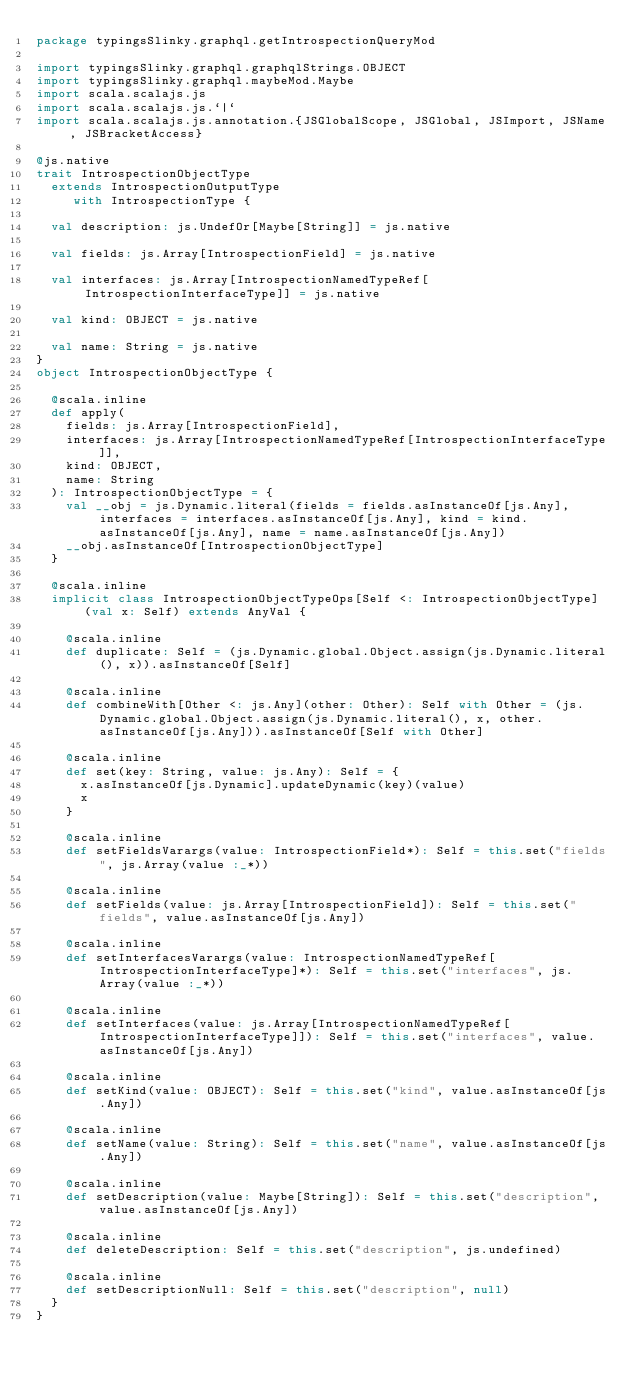Convert code to text. <code><loc_0><loc_0><loc_500><loc_500><_Scala_>package typingsSlinky.graphql.getIntrospectionQueryMod

import typingsSlinky.graphql.graphqlStrings.OBJECT
import typingsSlinky.graphql.maybeMod.Maybe
import scala.scalajs.js
import scala.scalajs.js.`|`
import scala.scalajs.js.annotation.{JSGlobalScope, JSGlobal, JSImport, JSName, JSBracketAccess}

@js.native
trait IntrospectionObjectType
  extends IntrospectionOutputType
     with IntrospectionType {
  
  val description: js.UndefOr[Maybe[String]] = js.native
  
  val fields: js.Array[IntrospectionField] = js.native
  
  val interfaces: js.Array[IntrospectionNamedTypeRef[IntrospectionInterfaceType]] = js.native
  
  val kind: OBJECT = js.native
  
  val name: String = js.native
}
object IntrospectionObjectType {
  
  @scala.inline
  def apply(
    fields: js.Array[IntrospectionField],
    interfaces: js.Array[IntrospectionNamedTypeRef[IntrospectionInterfaceType]],
    kind: OBJECT,
    name: String
  ): IntrospectionObjectType = {
    val __obj = js.Dynamic.literal(fields = fields.asInstanceOf[js.Any], interfaces = interfaces.asInstanceOf[js.Any], kind = kind.asInstanceOf[js.Any], name = name.asInstanceOf[js.Any])
    __obj.asInstanceOf[IntrospectionObjectType]
  }
  
  @scala.inline
  implicit class IntrospectionObjectTypeOps[Self <: IntrospectionObjectType] (val x: Self) extends AnyVal {
    
    @scala.inline
    def duplicate: Self = (js.Dynamic.global.Object.assign(js.Dynamic.literal(), x)).asInstanceOf[Self]
    
    @scala.inline
    def combineWith[Other <: js.Any](other: Other): Self with Other = (js.Dynamic.global.Object.assign(js.Dynamic.literal(), x, other.asInstanceOf[js.Any])).asInstanceOf[Self with Other]
    
    @scala.inline
    def set(key: String, value: js.Any): Self = {
      x.asInstanceOf[js.Dynamic].updateDynamic(key)(value)
      x
    }
    
    @scala.inline
    def setFieldsVarargs(value: IntrospectionField*): Self = this.set("fields", js.Array(value :_*))
    
    @scala.inline
    def setFields(value: js.Array[IntrospectionField]): Self = this.set("fields", value.asInstanceOf[js.Any])
    
    @scala.inline
    def setInterfacesVarargs(value: IntrospectionNamedTypeRef[IntrospectionInterfaceType]*): Self = this.set("interfaces", js.Array(value :_*))
    
    @scala.inline
    def setInterfaces(value: js.Array[IntrospectionNamedTypeRef[IntrospectionInterfaceType]]): Self = this.set("interfaces", value.asInstanceOf[js.Any])
    
    @scala.inline
    def setKind(value: OBJECT): Self = this.set("kind", value.asInstanceOf[js.Any])
    
    @scala.inline
    def setName(value: String): Self = this.set("name", value.asInstanceOf[js.Any])
    
    @scala.inline
    def setDescription(value: Maybe[String]): Self = this.set("description", value.asInstanceOf[js.Any])
    
    @scala.inline
    def deleteDescription: Self = this.set("description", js.undefined)
    
    @scala.inline
    def setDescriptionNull: Self = this.set("description", null)
  }
}
</code> 